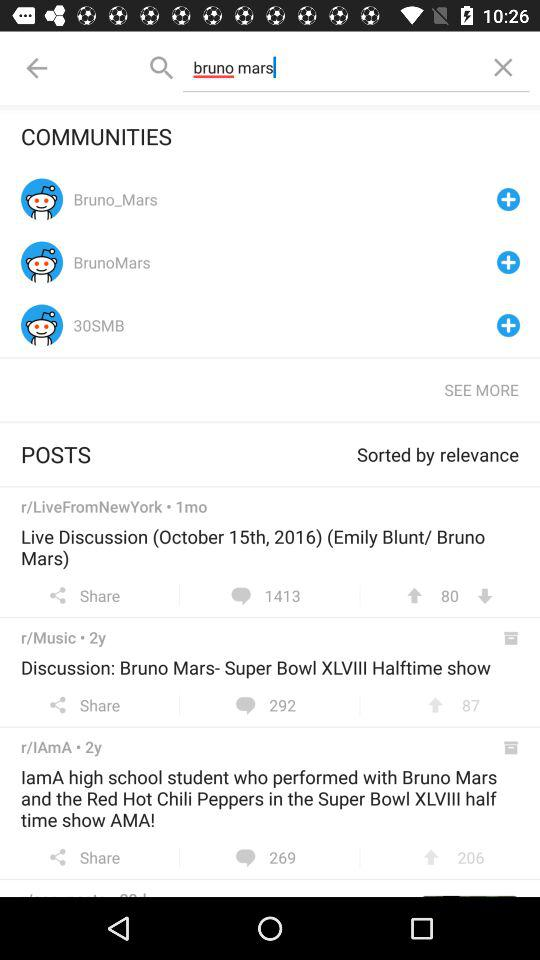How many people download discussion ; bruno mars-super bowl?
When the provided information is insufficient, respond with <no answer>. <no answer> 